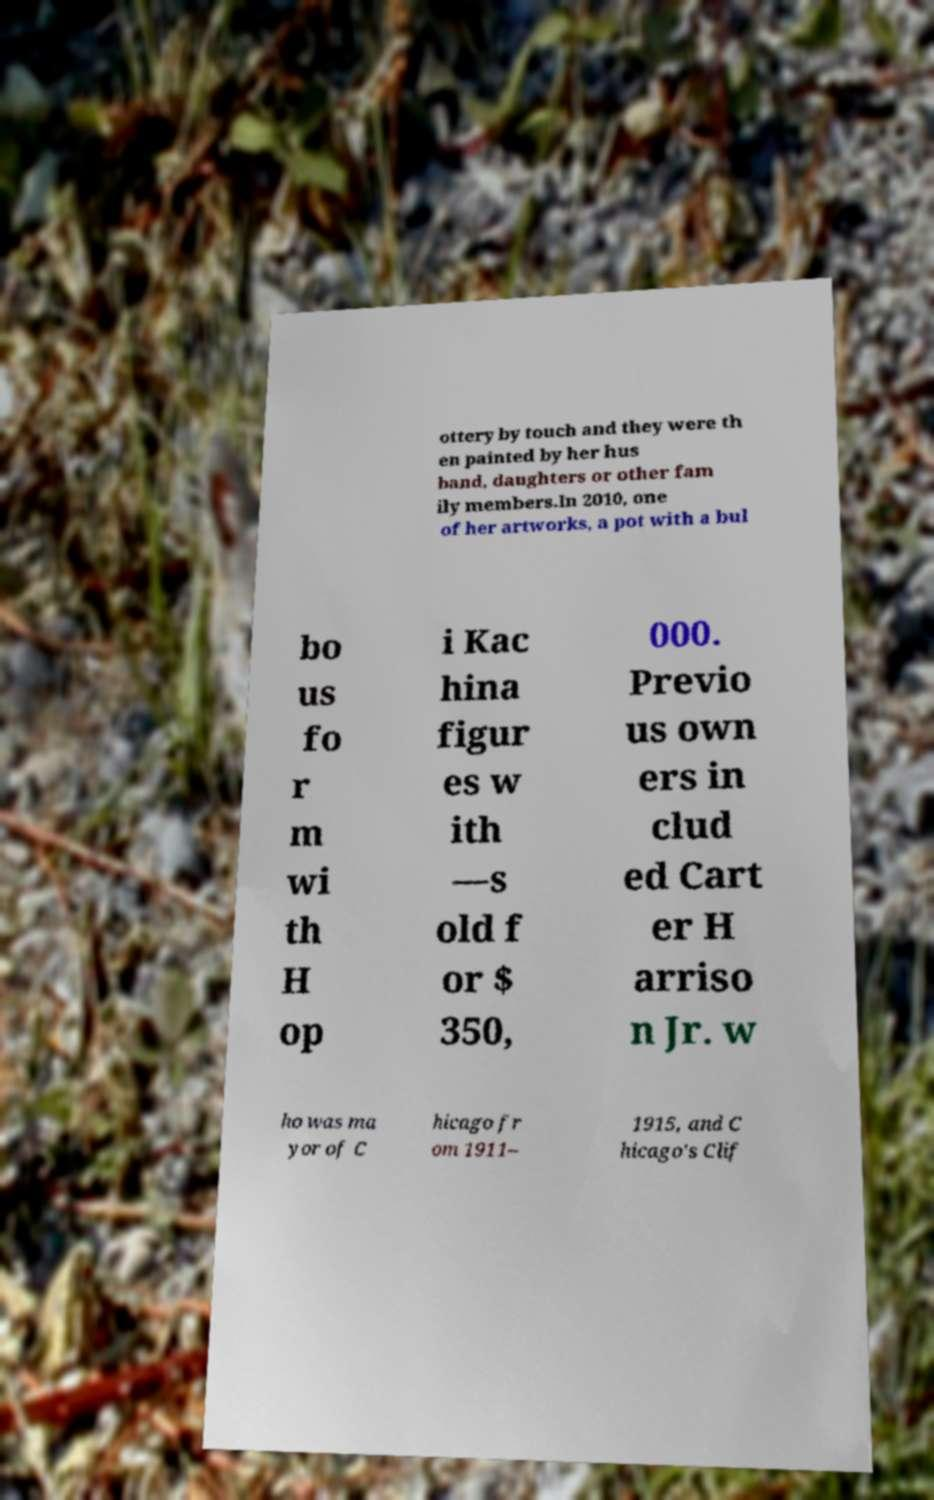What messages or text are displayed in this image? I need them in a readable, typed format. ottery by touch and they were th en painted by her hus band, daughters or other fam ily members.In 2010, one of her artworks, a pot with a bul bo us fo r m wi th H op i Kac hina figur es w ith —s old f or $ 350, 000. Previo us own ers in clud ed Cart er H arriso n Jr. w ho was ma yor of C hicago fr om 1911– 1915, and C hicago's Clif 